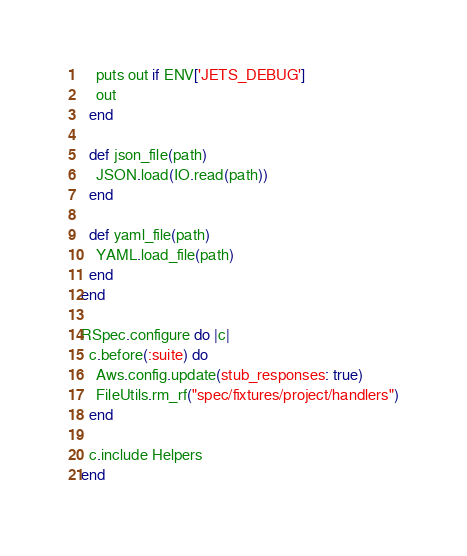<code> <loc_0><loc_0><loc_500><loc_500><_Ruby_>    puts out if ENV['JETS_DEBUG']
    out
  end

  def json_file(path)
    JSON.load(IO.read(path))
  end

  def yaml_file(path)
    YAML.load_file(path)
  end
end

RSpec.configure do |c|
  c.before(:suite) do
    Aws.config.update(stub_responses: true)
    FileUtils.rm_rf("spec/fixtures/project/handlers")
  end

  c.include Helpers
end
</code> 